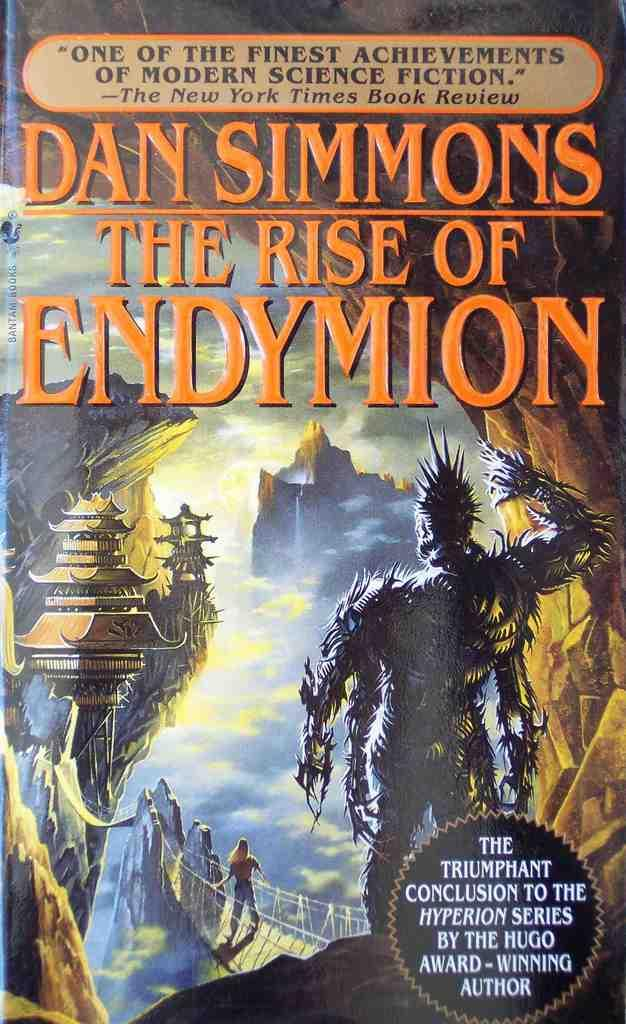<image>
Create a compact narrative representing the image presented. A book by Dan Simmons titled " The Rise Of Endymion". 